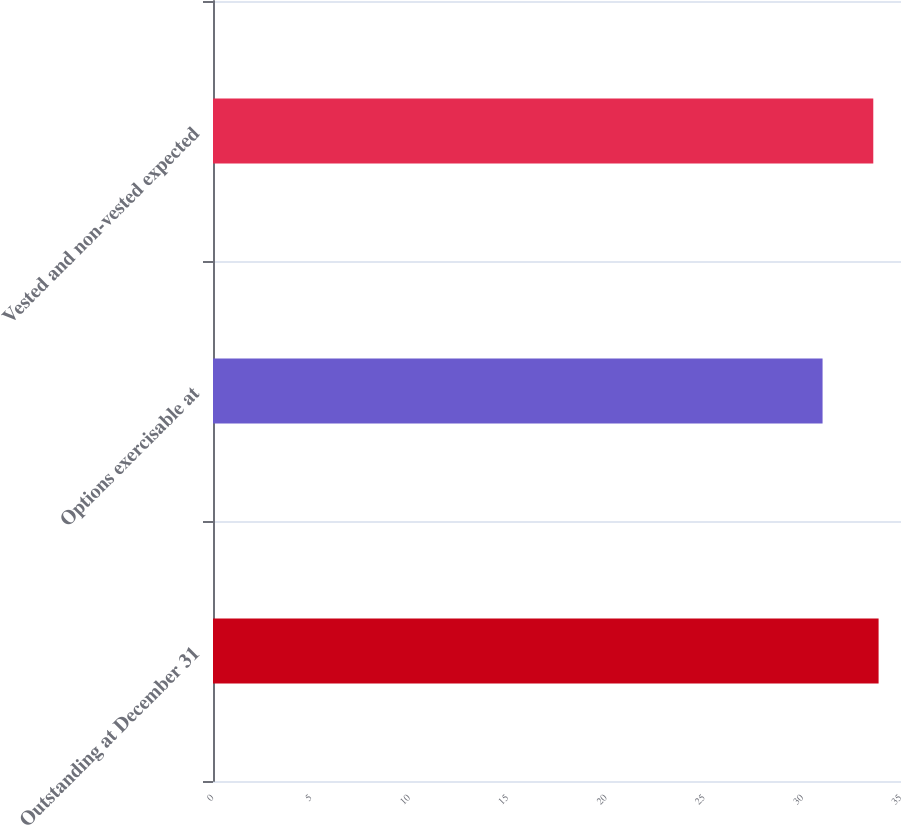Convert chart to OTSL. <chart><loc_0><loc_0><loc_500><loc_500><bar_chart><fcel>Outstanding at December 31<fcel>Options exercisable at<fcel>Vested and non-vested expected<nl><fcel>33.86<fcel>31.01<fcel>33.59<nl></chart> 